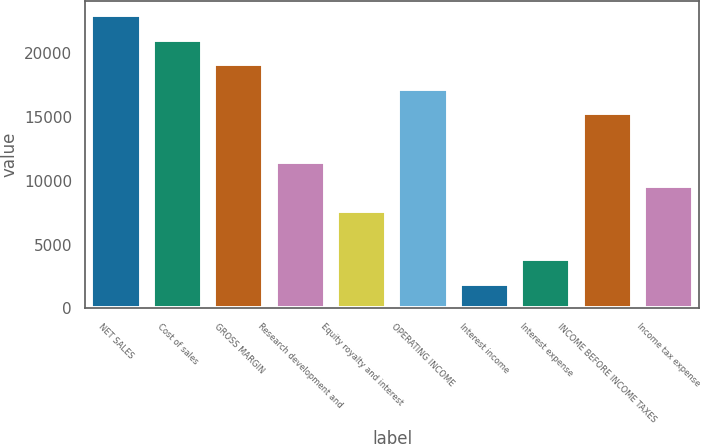Convert chart to OTSL. <chart><loc_0><loc_0><loc_500><loc_500><bar_chart><fcel>NET SALES<fcel>Cost of sales<fcel>GROSS MARGIN<fcel>Research development and<fcel>Equity royalty and interest<fcel>OPERATING INCOME<fcel>Interest income<fcel>Interest expense<fcel>INCOME BEFORE INCOME TAXES<fcel>Income tax expense<nl><fcel>22930.5<fcel>21020.3<fcel>19110<fcel>11469.2<fcel>7648.72<fcel>17199.8<fcel>1918.06<fcel>3828.28<fcel>15289.6<fcel>9558.94<nl></chart> 